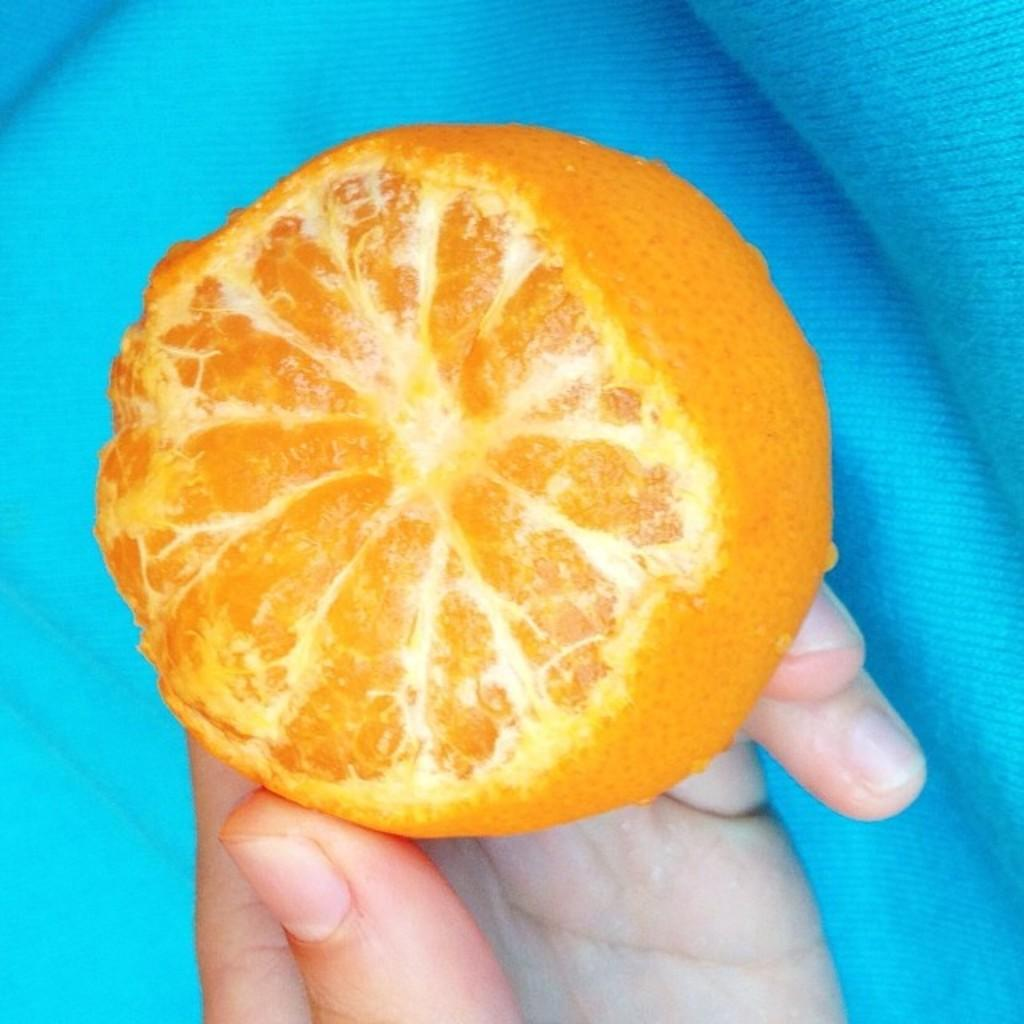What is the person's hand holding in the image? There is a person's hand holding a fruit in the image. Can you describe any other objects or elements in the image? There is a blue colored cloth in the image. What type of hair can be seen on the person's head in the image? There is no person's head visible in the image, only a hand holding a fruit and a blue colored cloth. 